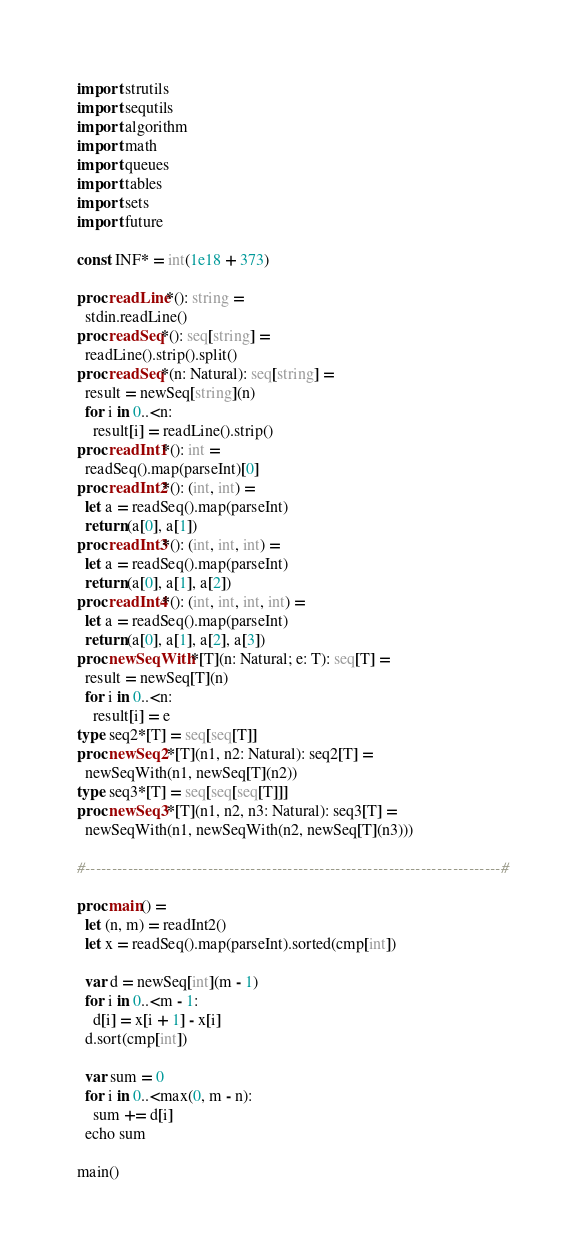Convert code to text. <code><loc_0><loc_0><loc_500><loc_500><_Nim_>import strutils
import sequtils
import algorithm
import math
import queues
import tables
import sets
import future

const INF* = int(1e18 + 373)

proc readLine*(): string =
  stdin.readLine()
proc readSeq*(): seq[string] =
  readLine().strip().split()
proc readSeq*(n: Natural): seq[string] =
  result = newSeq[string](n)
  for i in 0..<n:
    result[i] = readLine().strip()
proc readInt1*(): int =
  readSeq().map(parseInt)[0]
proc readInt2*(): (int, int) =
  let a = readSeq().map(parseInt)
  return (a[0], a[1])
proc readInt3*(): (int, int, int) =
  let a = readSeq().map(parseInt)
  return (a[0], a[1], a[2])
proc readInt4*(): (int, int, int, int) =
  let a = readSeq().map(parseInt)
  return (a[0], a[1], a[2], a[3])
proc newSeqWith*[T](n: Natural; e: T): seq[T] =
  result = newSeq[T](n)
  for i in 0..<n:
    result[i] = e
type seq2*[T] = seq[seq[T]]
proc newSeq2*[T](n1, n2: Natural): seq2[T] =
  newSeqWith(n1, newSeq[T](n2))
type seq3*[T] = seq[seq[seq[T]]]
proc newSeq3*[T](n1, n2, n3: Natural): seq3[T] =
  newSeqWith(n1, newSeqWith(n2, newSeq[T](n3)))

#------------------------------------------------------------------------------#

proc main() =
  let (n, m) = readInt2()
  let x = readSeq().map(parseInt).sorted(cmp[int])

  var d = newSeq[int](m - 1)
  for i in 0..<m - 1:
    d[i] = x[i + 1] - x[i]
  d.sort(cmp[int])

  var sum = 0
  for i in 0..<max(0, m - n):
    sum += d[i]
  echo sum

main()

</code> 